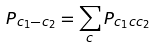Convert formula to latex. <formula><loc_0><loc_0><loc_500><loc_500>P _ { c _ { 1 } - c _ { 2 } } = \sum _ { c } P _ { c _ { 1 } c c _ { 2 } }</formula> 